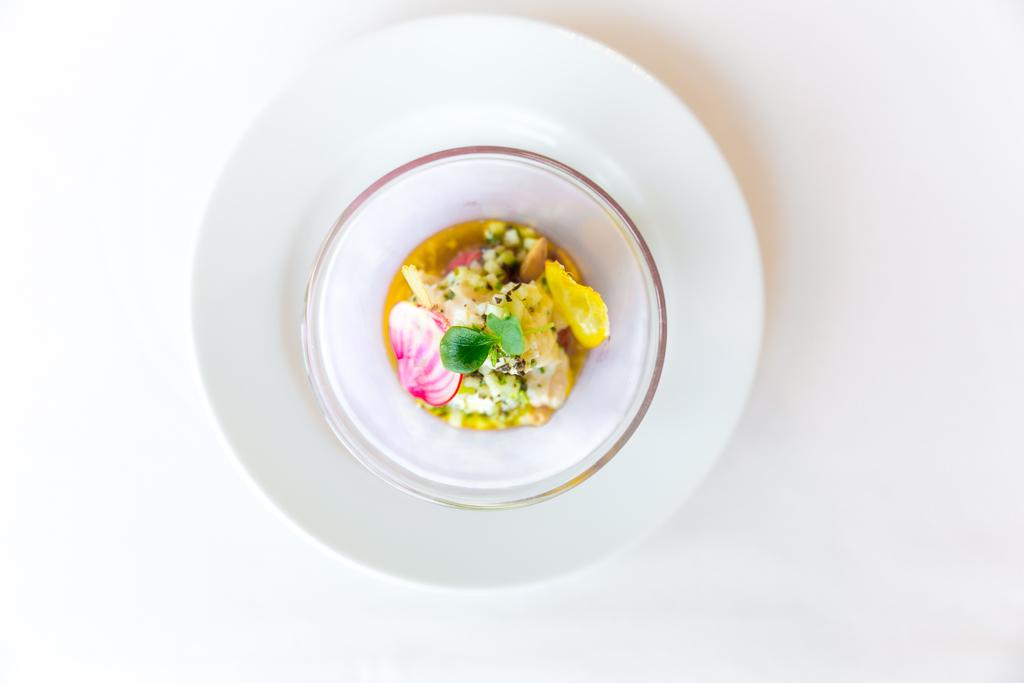What is the main subject of the image? The main subject of the image is food on a plate. Where is the plate located in the image? The plate is in the center of the image. What type of carriage can be seen pulling a flower in the image? There is no carriage or flower present in the image; it only features food on a plate. 